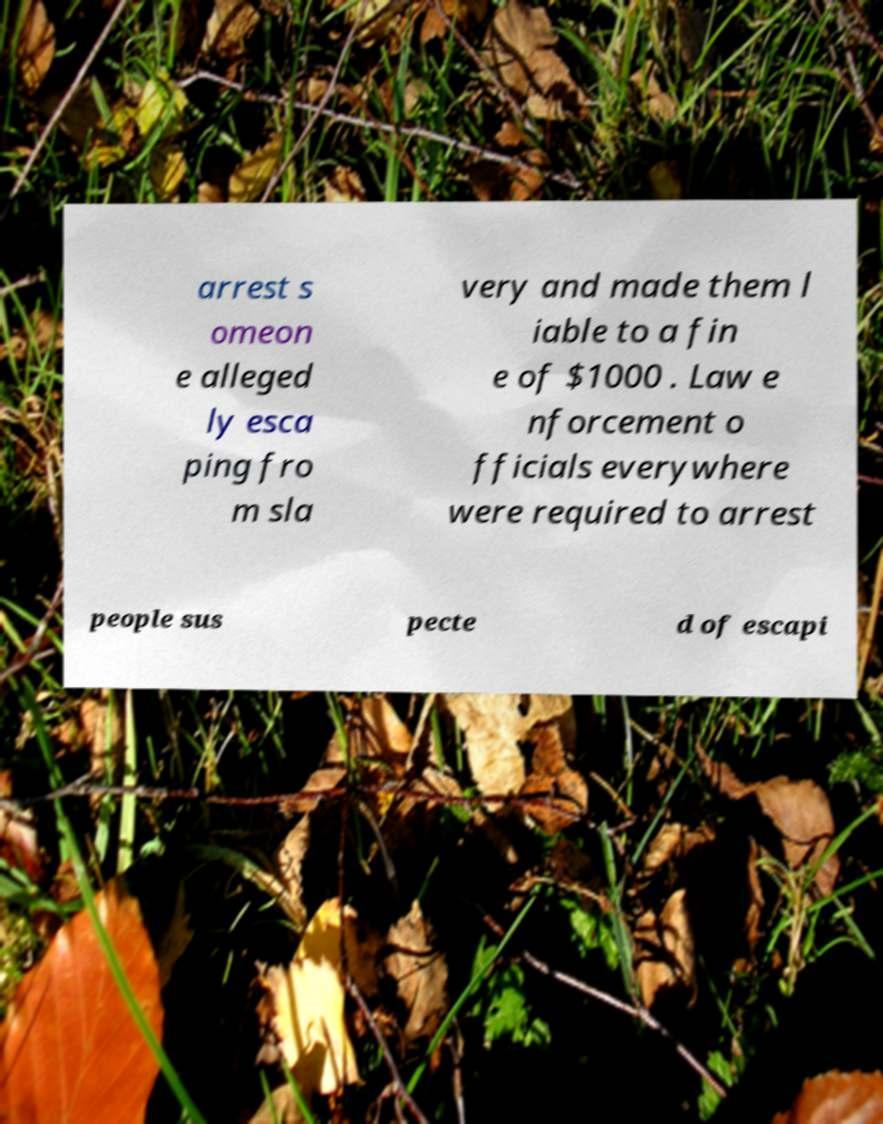Could you assist in decoding the text presented in this image and type it out clearly? arrest s omeon e alleged ly esca ping fro m sla very and made them l iable to a fin e of $1000 . Law e nforcement o fficials everywhere were required to arrest people sus pecte d of escapi 